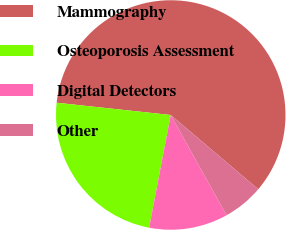Convert chart. <chart><loc_0><loc_0><loc_500><loc_500><pie_chart><fcel>Mammography<fcel>Osteoporosis Assessment<fcel>Digital Detectors<fcel>Other<nl><fcel>59.5%<fcel>23.69%<fcel>11.1%<fcel>5.72%<nl></chart> 